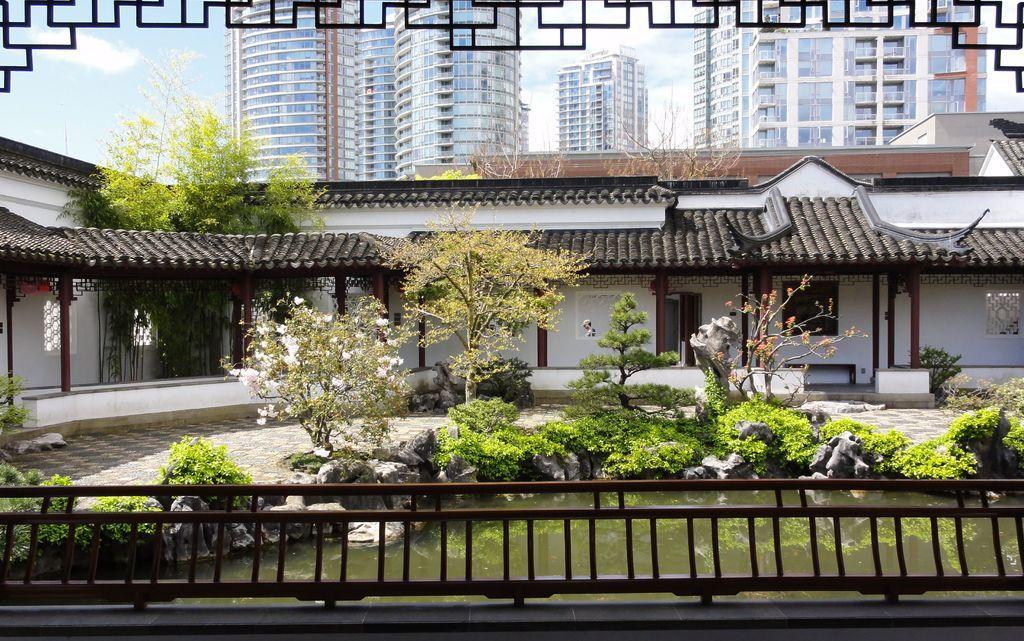Can you describe this image briefly? This picture shows few buildings and we see trees and plants and we see water and a blue cloudy sky. 